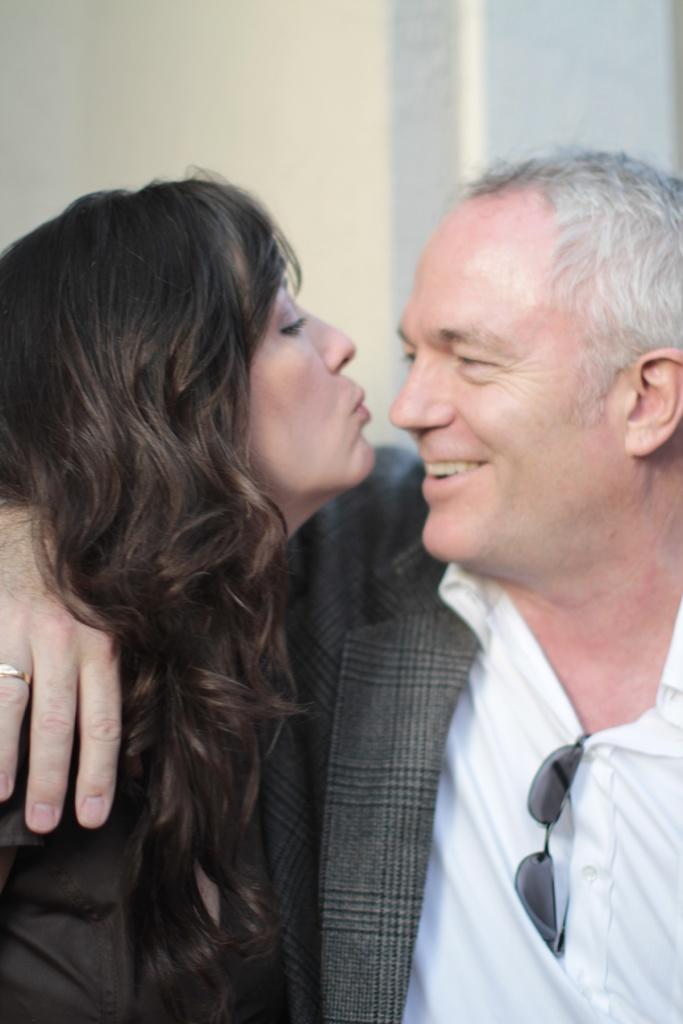What is the man in the image wearing? The man in the image is wearing a white shirt. What is the man's facial expression in the image? The man is smiling in the image. Who else is present in the image? There is a lady in the image. What can be seen in the background of the image? There is a wall in the background of the image. What type of hand is the man using to perform arithmetic in the image? There is no hand or arithmetic activity present in the image. What color is the cap the man is wearing in the image? The man is not wearing a cap in the image; he is wearing a white shirt. 